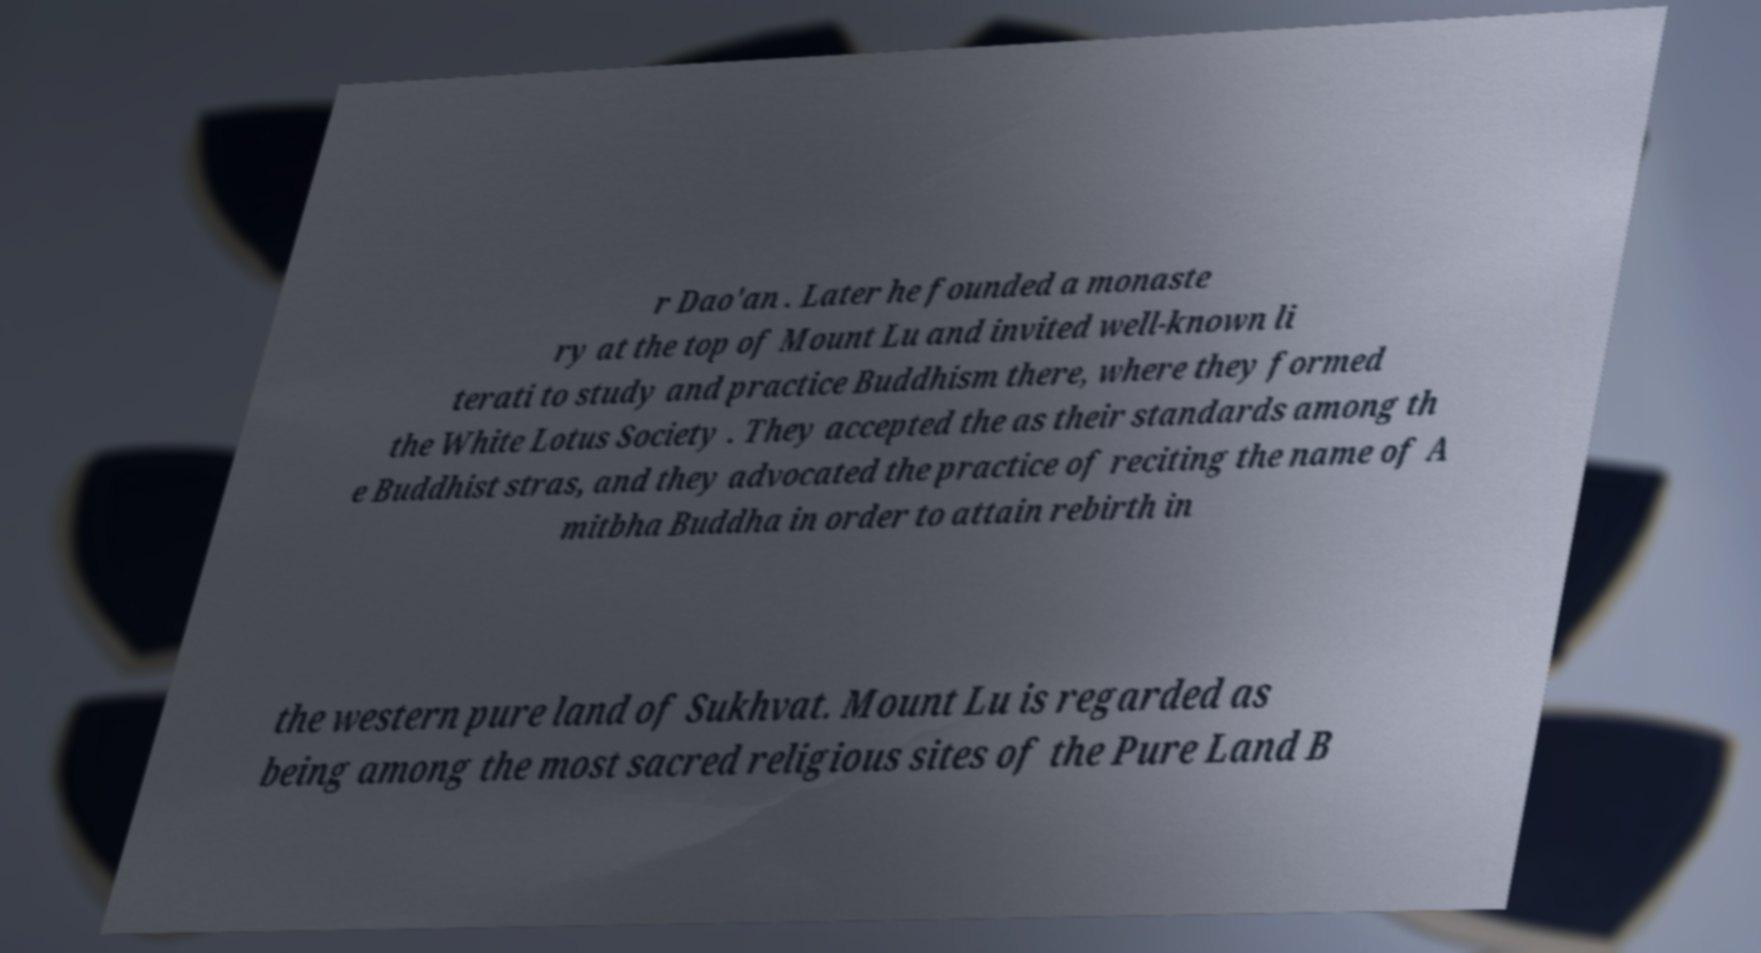What messages or text are displayed in this image? I need them in a readable, typed format. r Dao'an . Later he founded a monaste ry at the top of Mount Lu and invited well-known li terati to study and practice Buddhism there, where they formed the White Lotus Society . They accepted the as their standards among th e Buddhist stras, and they advocated the practice of reciting the name of A mitbha Buddha in order to attain rebirth in the western pure land of Sukhvat. Mount Lu is regarded as being among the most sacred religious sites of the Pure Land B 